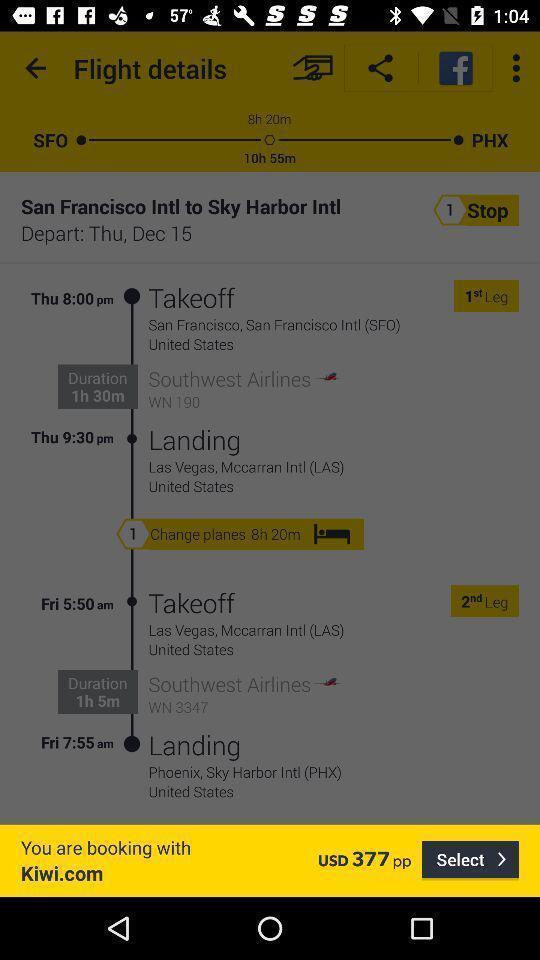Describe the visual elements of this screenshot. Pop-up shows booking details in a travel app. 